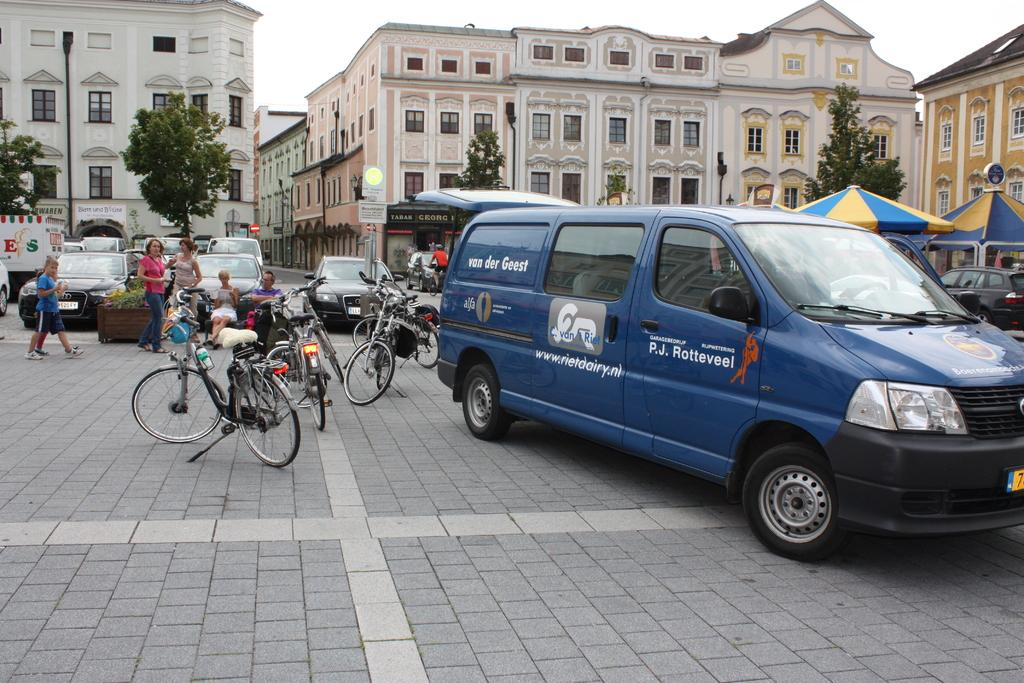<image>
Write a terse but informative summary of the picture. A van is parked beside a number of bikes and belongs to a Dutch dairy. 